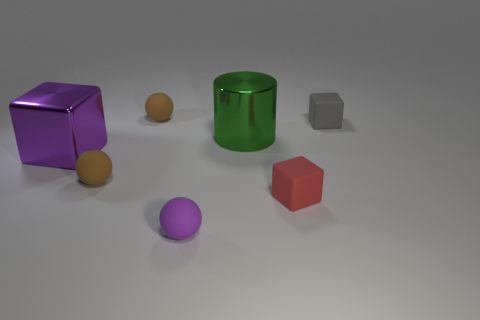Add 1 tiny blue rubber things. How many objects exist? 8 Subtract all cylinders. How many objects are left? 6 Add 3 small brown matte balls. How many small brown matte balls exist? 5 Subtract 0 yellow blocks. How many objects are left? 7 Subtract all green things. Subtract all rubber spheres. How many objects are left? 3 Add 1 large purple blocks. How many large purple blocks are left? 2 